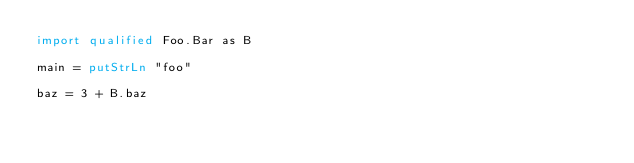<code> <loc_0><loc_0><loc_500><loc_500><_Haskell_>import qualified Foo.Bar as B

main = putStrLn "foo"

baz = 3 + B.baz
</code> 